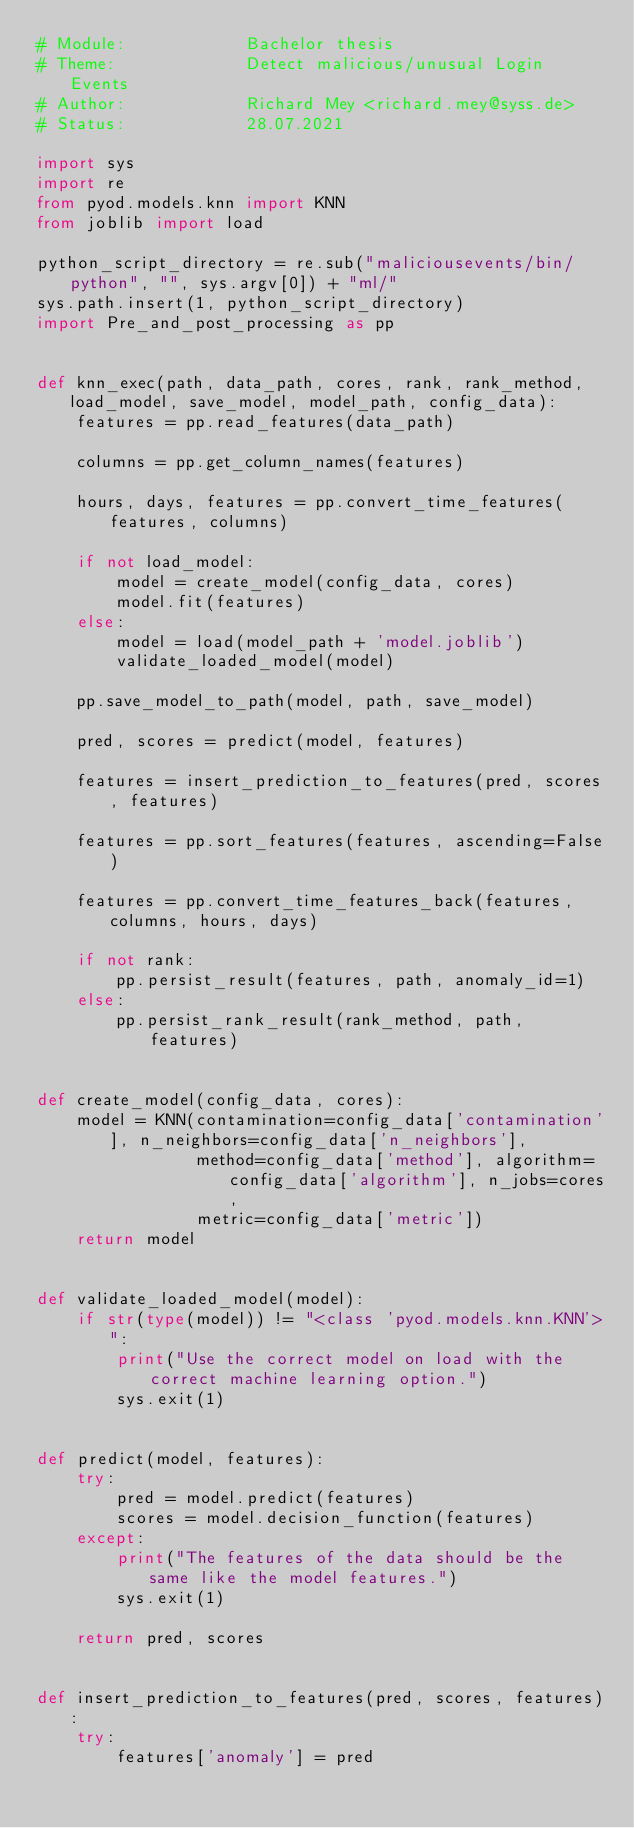<code> <loc_0><loc_0><loc_500><loc_500><_Python_># Module:            Bachelor thesis
# Theme:             Detect malicious/unusual Login Events
# Author:            Richard Mey <richard.mey@syss.de>
# Status:            28.07.2021

import sys
import re
from pyod.models.knn import KNN
from joblib import load

python_script_directory = re.sub("maliciousevents/bin/python", "", sys.argv[0]) + "ml/"
sys.path.insert(1, python_script_directory)
import Pre_and_post_processing as pp


def knn_exec(path, data_path, cores, rank, rank_method, load_model, save_model, model_path, config_data):
    features = pp.read_features(data_path)

    columns = pp.get_column_names(features)

    hours, days, features = pp.convert_time_features(features, columns)

    if not load_model:
        model = create_model(config_data, cores)
        model.fit(features)
    else:
        model = load(model_path + 'model.joblib')
        validate_loaded_model(model)

    pp.save_model_to_path(model, path, save_model)

    pred, scores = predict(model, features)

    features = insert_prediction_to_features(pred, scores, features)

    features = pp.sort_features(features, ascending=False)

    features = pp.convert_time_features_back(features, columns, hours, days)

    if not rank:
        pp.persist_result(features, path, anomaly_id=1)
    else:
        pp.persist_rank_result(rank_method, path, features)


def create_model(config_data, cores):
    model = KNN(contamination=config_data['contamination'], n_neighbors=config_data['n_neighbors'],
                method=config_data['method'], algorithm=config_data['algorithm'], n_jobs=cores,
                metric=config_data['metric'])
    return model


def validate_loaded_model(model):
    if str(type(model)) != "<class 'pyod.models.knn.KNN'>":
        print("Use the correct model on load with the correct machine learning option.")
        sys.exit(1)


def predict(model, features):
    try:
        pred = model.predict(features)
        scores = model.decision_function(features)
    except:
        print("The features of the data should be the same like the model features.")
        sys.exit(1)

    return pred, scores


def insert_prediction_to_features(pred, scores, features):
    try:
        features['anomaly'] = pred</code> 